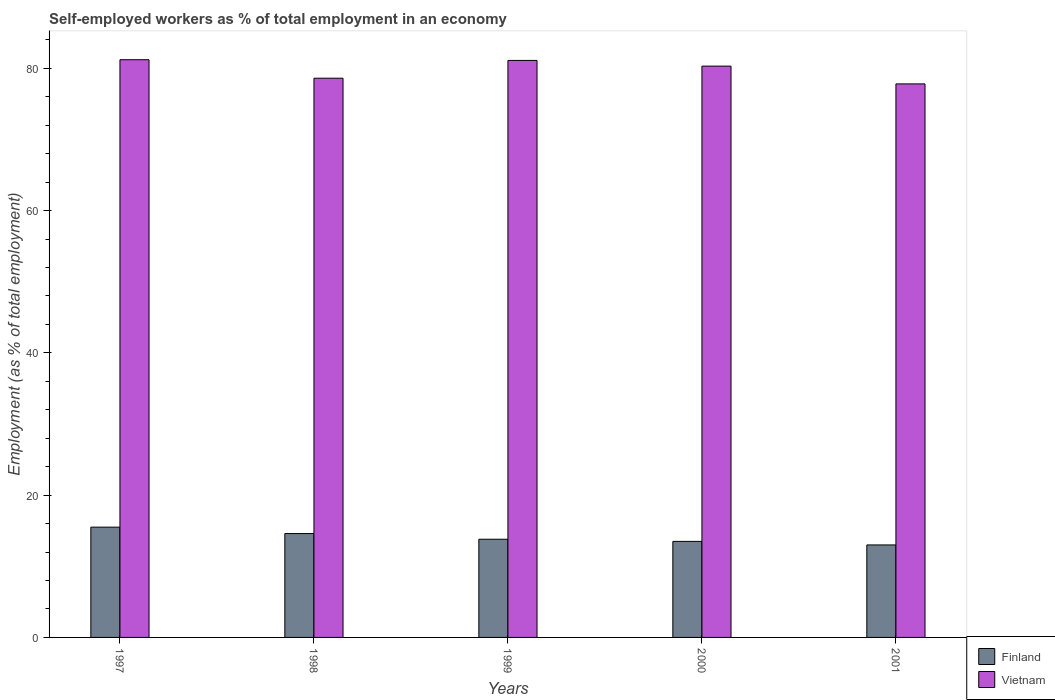Are the number of bars on each tick of the X-axis equal?
Ensure brevity in your answer.  Yes. How many bars are there on the 1st tick from the left?
Ensure brevity in your answer.  2. What is the label of the 1st group of bars from the left?
Offer a very short reply. 1997. What is the percentage of self-employed workers in Finland in 2001?
Your response must be concise. 13. Across all years, what is the minimum percentage of self-employed workers in Vietnam?
Provide a short and direct response. 77.8. In which year was the percentage of self-employed workers in Finland maximum?
Your answer should be very brief. 1997. In which year was the percentage of self-employed workers in Finland minimum?
Give a very brief answer. 2001. What is the total percentage of self-employed workers in Vietnam in the graph?
Provide a short and direct response. 399. What is the difference between the percentage of self-employed workers in Finland in 1998 and that in 2000?
Give a very brief answer. 1.1. What is the difference between the percentage of self-employed workers in Finland in 2000 and the percentage of self-employed workers in Vietnam in 1999?
Give a very brief answer. -67.6. What is the average percentage of self-employed workers in Finland per year?
Give a very brief answer. 14.08. In the year 1998, what is the difference between the percentage of self-employed workers in Vietnam and percentage of self-employed workers in Finland?
Offer a very short reply. 64. In how many years, is the percentage of self-employed workers in Vietnam greater than 12 %?
Make the answer very short. 5. What is the ratio of the percentage of self-employed workers in Finland in 1997 to that in 2000?
Provide a short and direct response. 1.15. What is the difference between the highest and the second highest percentage of self-employed workers in Finland?
Keep it short and to the point. 0.9. What is the difference between the highest and the lowest percentage of self-employed workers in Finland?
Offer a terse response. 2.5. What does the 2nd bar from the left in 1997 represents?
Give a very brief answer. Vietnam. What does the 2nd bar from the right in 1999 represents?
Provide a succinct answer. Finland. How many bars are there?
Give a very brief answer. 10. Where does the legend appear in the graph?
Provide a succinct answer. Bottom right. How many legend labels are there?
Offer a terse response. 2. What is the title of the graph?
Provide a short and direct response. Self-employed workers as % of total employment in an economy. What is the label or title of the Y-axis?
Ensure brevity in your answer.  Employment (as % of total employment). What is the Employment (as % of total employment) of Finland in 1997?
Your answer should be very brief. 15.5. What is the Employment (as % of total employment) in Vietnam in 1997?
Offer a terse response. 81.2. What is the Employment (as % of total employment) of Finland in 1998?
Your answer should be compact. 14.6. What is the Employment (as % of total employment) in Vietnam in 1998?
Give a very brief answer. 78.6. What is the Employment (as % of total employment) of Finland in 1999?
Ensure brevity in your answer.  13.8. What is the Employment (as % of total employment) in Vietnam in 1999?
Make the answer very short. 81.1. What is the Employment (as % of total employment) in Finland in 2000?
Offer a very short reply. 13.5. What is the Employment (as % of total employment) of Vietnam in 2000?
Ensure brevity in your answer.  80.3. What is the Employment (as % of total employment) of Vietnam in 2001?
Ensure brevity in your answer.  77.8. Across all years, what is the maximum Employment (as % of total employment) in Finland?
Offer a terse response. 15.5. Across all years, what is the maximum Employment (as % of total employment) of Vietnam?
Provide a short and direct response. 81.2. Across all years, what is the minimum Employment (as % of total employment) in Finland?
Offer a very short reply. 13. Across all years, what is the minimum Employment (as % of total employment) in Vietnam?
Your answer should be compact. 77.8. What is the total Employment (as % of total employment) of Finland in the graph?
Your response must be concise. 70.4. What is the total Employment (as % of total employment) in Vietnam in the graph?
Make the answer very short. 399. What is the difference between the Employment (as % of total employment) in Vietnam in 1997 and that in 1998?
Provide a short and direct response. 2.6. What is the difference between the Employment (as % of total employment) in Finland in 1997 and that in 1999?
Provide a short and direct response. 1.7. What is the difference between the Employment (as % of total employment) in Vietnam in 1997 and that in 1999?
Offer a terse response. 0.1. What is the difference between the Employment (as % of total employment) of Finland in 1997 and that in 2000?
Offer a terse response. 2. What is the difference between the Employment (as % of total employment) of Finland in 1997 and that in 2001?
Your answer should be very brief. 2.5. What is the difference between the Employment (as % of total employment) in Vietnam in 1998 and that in 1999?
Your answer should be very brief. -2.5. What is the difference between the Employment (as % of total employment) of Finland in 1998 and that in 2000?
Your answer should be compact. 1.1. What is the difference between the Employment (as % of total employment) of Finland in 1998 and that in 2001?
Your response must be concise. 1.6. What is the difference between the Employment (as % of total employment) of Vietnam in 1998 and that in 2001?
Provide a short and direct response. 0.8. What is the difference between the Employment (as % of total employment) in Finland in 1999 and that in 2000?
Provide a succinct answer. 0.3. What is the difference between the Employment (as % of total employment) in Vietnam in 1999 and that in 2000?
Your response must be concise. 0.8. What is the difference between the Employment (as % of total employment) in Finland in 1999 and that in 2001?
Give a very brief answer. 0.8. What is the difference between the Employment (as % of total employment) of Finland in 2000 and that in 2001?
Your answer should be very brief. 0.5. What is the difference between the Employment (as % of total employment) of Vietnam in 2000 and that in 2001?
Keep it short and to the point. 2.5. What is the difference between the Employment (as % of total employment) of Finland in 1997 and the Employment (as % of total employment) of Vietnam in 1998?
Provide a succinct answer. -63.1. What is the difference between the Employment (as % of total employment) of Finland in 1997 and the Employment (as % of total employment) of Vietnam in 1999?
Keep it short and to the point. -65.6. What is the difference between the Employment (as % of total employment) of Finland in 1997 and the Employment (as % of total employment) of Vietnam in 2000?
Your answer should be very brief. -64.8. What is the difference between the Employment (as % of total employment) of Finland in 1997 and the Employment (as % of total employment) of Vietnam in 2001?
Give a very brief answer. -62.3. What is the difference between the Employment (as % of total employment) in Finland in 1998 and the Employment (as % of total employment) in Vietnam in 1999?
Your answer should be compact. -66.5. What is the difference between the Employment (as % of total employment) of Finland in 1998 and the Employment (as % of total employment) of Vietnam in 2000?
Make the answer very short. -65.7. What is the difference between the Employment (as % of total employment) of Finland in 1998 and the Employment (as % of total employment) of Vietnam in 2001?
Ensure brevity in your answer.  -63.2. What is the difference between the Employment (as % of total employment) in Finland in 1999 and the Employment (as % of total employment) in Vietnam in 2000?
Make the answer very short. -66.5. What is the difference between the Employment (as % of total employment) in Finland in 1999 and the Employment (as % of total employment) in Vietnam in 2001?
Your response must be concise. -64. What is the difference between the Employment (as % of total employment) of Finland in 2000 and the Employment (as % of total employment) of Vietnam in 2001?
Make the answer very short. -64.3. What is the average Employment (as % of total employment) of Finland per year?
Give a very brief answer. 14.08. What is the average Employment (as % of total employment) in Vietnam per year?
Ensure brevity in your answer.  79.8. In the year 1997, what is the difference between the Employment (as % of total employment) of Finland and Employment (as % of total employment) of Vietnam?
Make the answer very short. -65.7. In the year 1998, what is the difference between the Employment (as % of total employment) of Finland and Employment (as % of total employment) of Vietnam?
Ensure brevity in your answer.  -64. In the year 1999, what is the difference between the Employment (as % of total employment) of Finland and Employment (as % of total employment) of Vietnam?
Your answer should be compact. -67.3. In the year 2000, what is the difference between the Employment (as % of total employment) in Finland and Employment (as % of total employment) in Vietnam?
Provide a succinct answer. -66.8. In the year 2001, what is the difference between the Employment (as % of total employment) of Finland and Employment (as % of total employment) of Vietnam?
Offer a terse response. -64.8. What is the ratio of the Employment (as % of total employment) in Finland in 1997 to that in 1998?
Ensure brevity in your answer.  1.06. What is the ratio of the Employment (as % of total employment) in Vietnam in 1997 to that in 1998?
Provide a short and direct response. 1.03. What is the ratio of the Employment (as % of total employment) in Finland in 1997 to that in 1999?
Make the answer very short. 1.12. What is the ratio of the Employment (as % of total employment) in Vietnam in 1997 to that in 1999?
Make the answer very short. 1. What is the ratio of the Employment (as % of total employment) in Finland in 1997 to that in 2000?
Offer a terse response. 1.15. What is the ratio of the Employment (as % of total employment) of Vietnam in 1997 to that in 2000?
Offer a terse response. 1.01. What is the ratio of the Employment (as % of total employment) in Finland in 1997 to that in 2001?
Offer a very short reply. 1.19. What is the ratio of the Employment (as % of total employment) in Vietnam in 1997 to that in 2001?
Your answer should be compact. 1.04. What is the ratio of the Employment (as % of total employment) in Finland in 1998 to that in 1999?
Provide a short and direct response. 1.06. What is the ratio of the Employment (as % of total employment) of Vietnam in 1998 to that in 1999?
Provide a short and direct response. 0.97. What is the ratio of the Employment (as % of total employment) in Finland in 1998 to that in 2000?
Ensure brevity in your answer.  1.08. What is the ratio of the Employment (as % of total employment) in Vietnam in 1998 to that in 2000?
Keep it short and to the point. 0.98. What is the ratio of the Employment (as % of total employment) in Finland in 1998 to that in 2001?
Make the answer very short. 1.12. What is the ratio of the Employment (as % of total employment) of Vietnam in 1998 to that in 2001?
Your answer should be very brief. 1.01. What is the ratio of the Employment (as % of total employment) in Finland in 1999 to that in 2000?
Ensure brevity in your answer.  1.02. What is the ratio of the Employment (as % of total employment) of Finland in 1999 to that in 2001?
Provide a succinct answer. 1.06. What is the ratio of the Employment (as % of total employment) in Vietnam in 1999 to that in 2001?
Keep it short and to the point. 1.04. What is the ratio of the Employment (as % of total employment) of Vietnam in 2000 to that in 2001?
Give a very brief answer. 1.03. What is the difference between the highest and the lowest Employment (as % of total employment) of Finland?
Provide a short and direct response. 2.5. What is the difference between the highest and the lowest Employment (as % of total employment) of Vietnam?
Offer a terse response. 3.4. 